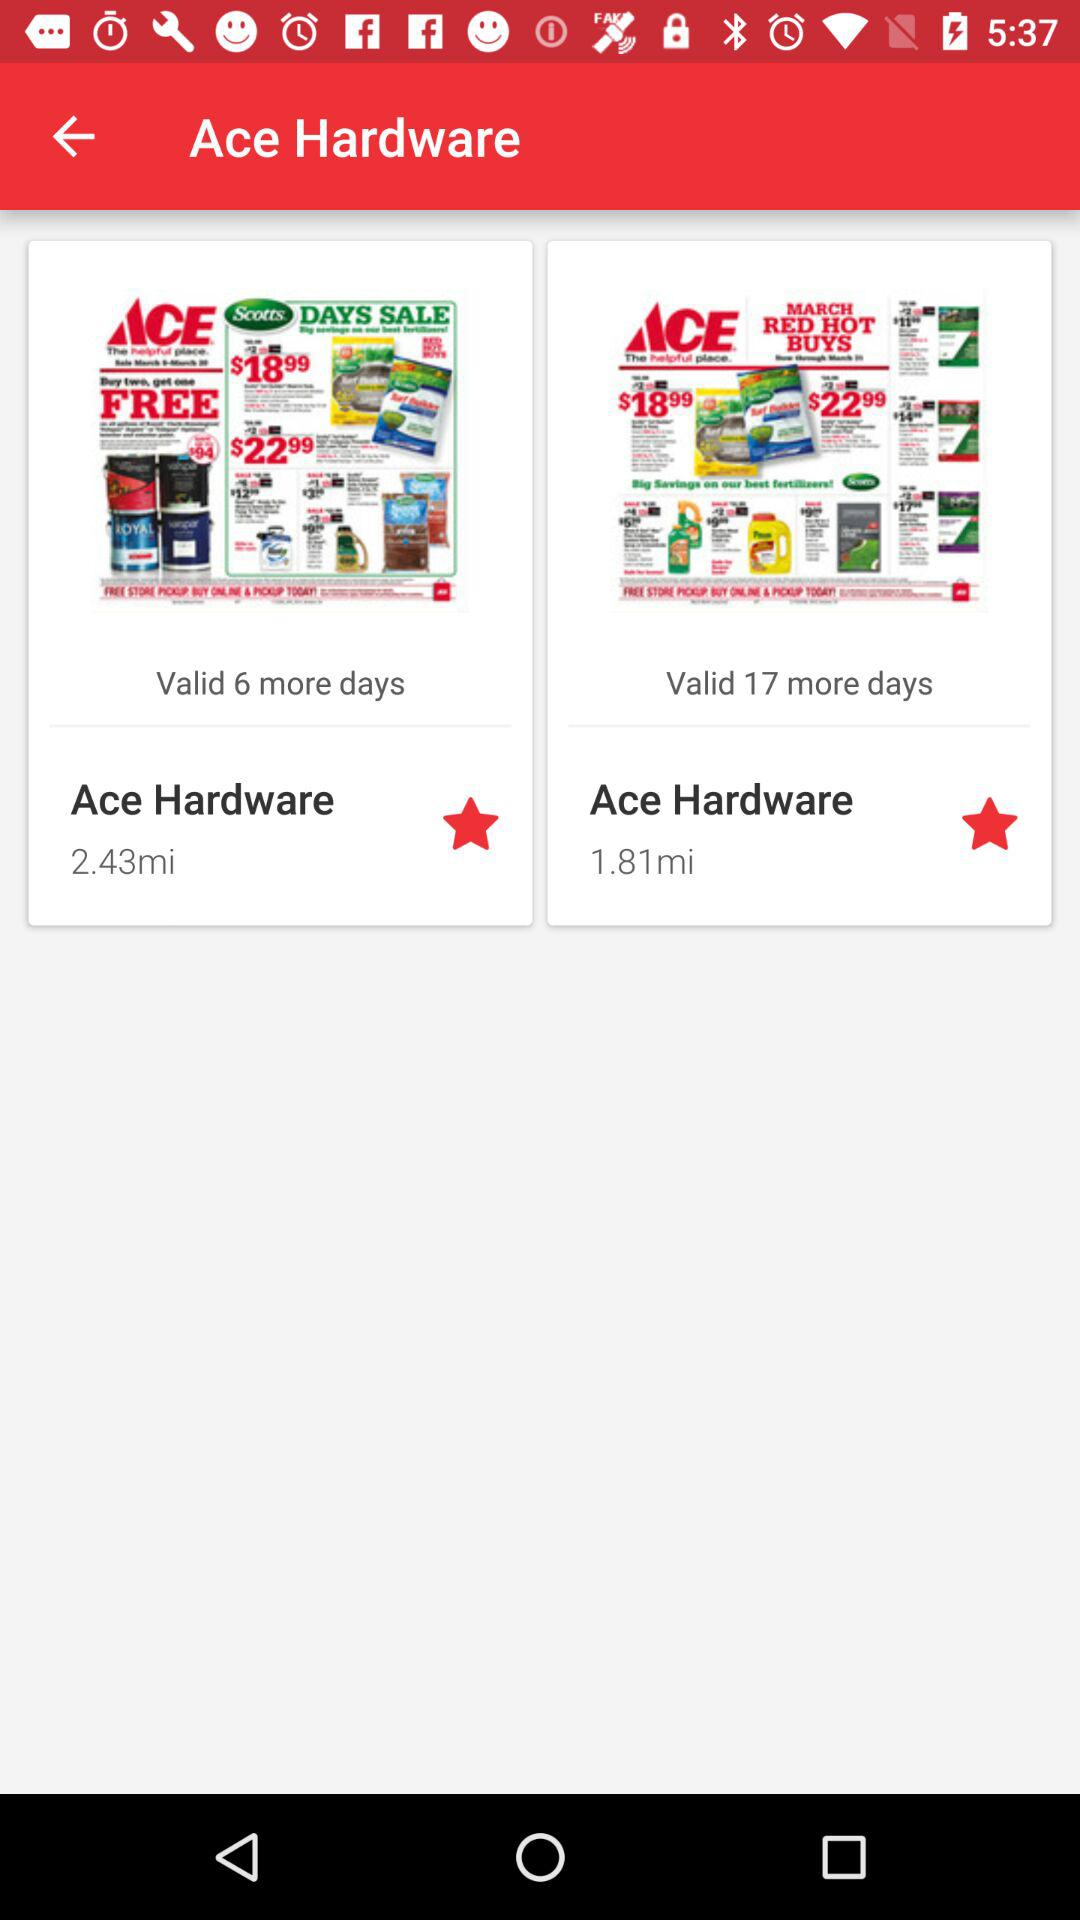What is the validity of day sales in Ace Hardware at 2.43 miles? The day's sales are valid for 6 more days. 